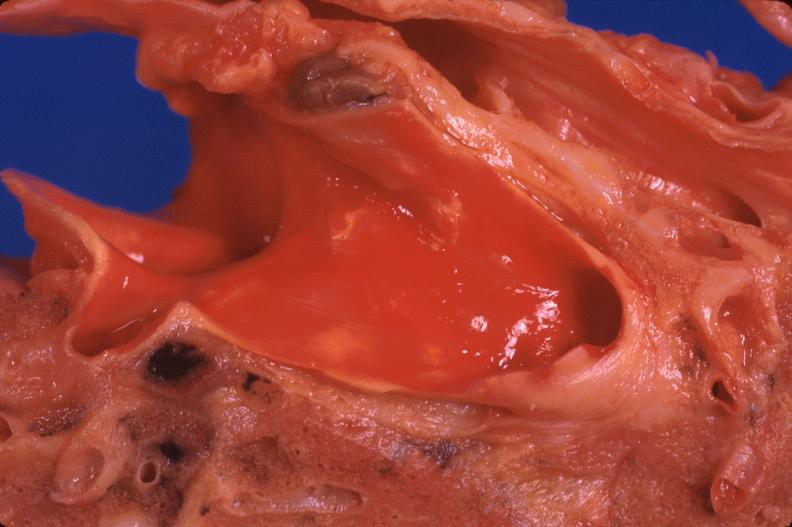where is this?
Answer the question using a single word or phrase. Lung 